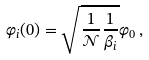Convert formula to latex. <formula><loc_0><loc_0><loc_500><loc_500>\varphi _ { i } ( 0 ) = \sqrt { \frac { 1 } { \mathcal { N } } \frac { 1 } { \beta _ { i } } } \varphi _ { 0 } \, ,</formula> 